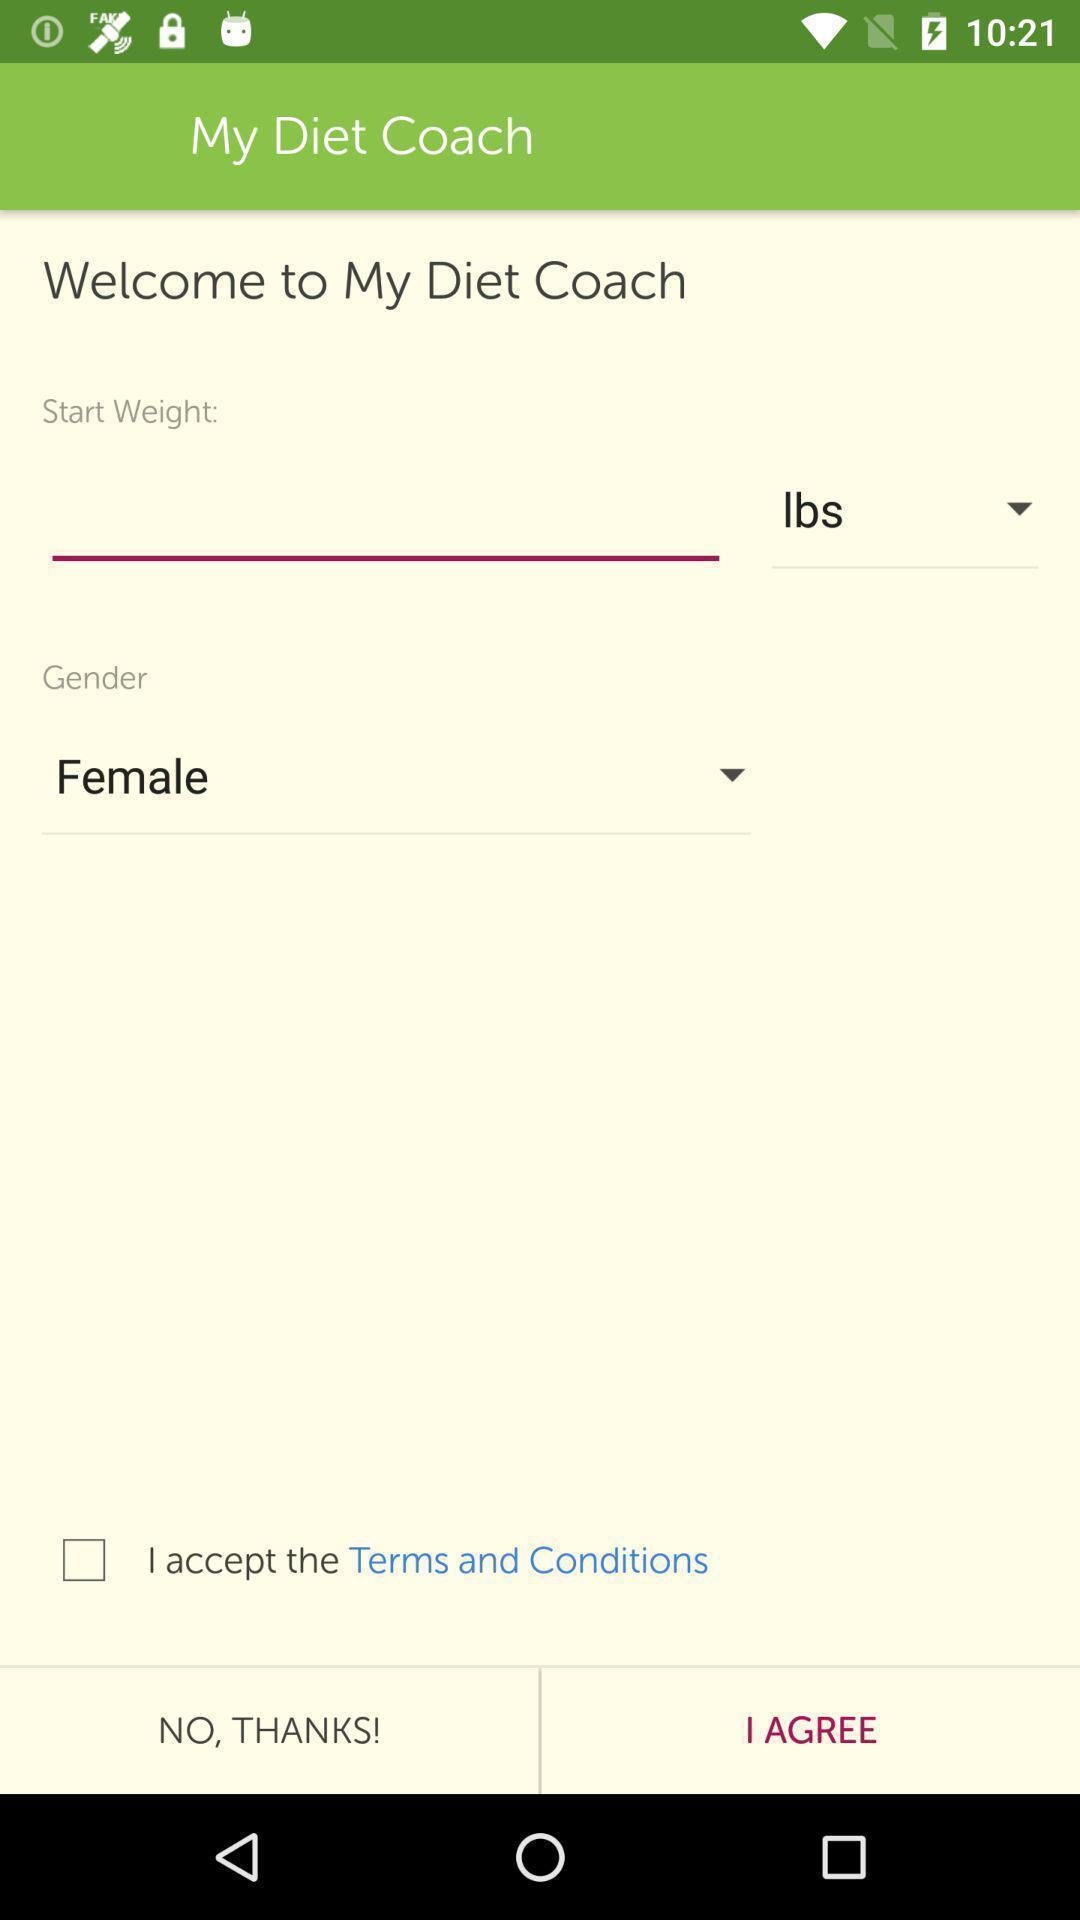Describe the key features of this screenshot. Welcome page for the diet fitness app. 